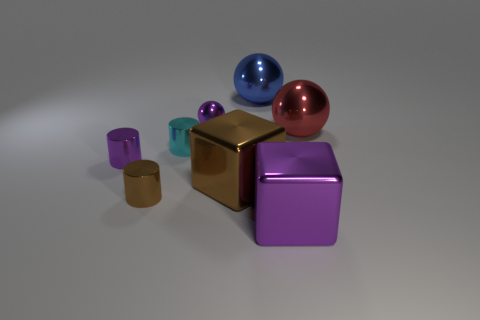How many other objects are there of the same material as the small sphere?
Make the answer very short. 7. What is the color of the big thing that is in front of the red sphere and behind the purple shiny cube?
Provide a succinct answer. Brown. Is the big block that is to the right of the large blue sphere made of the same material as the cube that is to the left of the blue ball?
Make the answer very short. Yes. Is the size of the brown metallic object on the left side of the purple ball the same as the tiny cyan cylinder?
Provide a short and direct response. Yes. There is a small ball; is it the same color as the metallic cube on the right side of the large blue object?
Provide a short and direct response. Yes. There is a big metallic object that is the same color as the small ball; what shape is it?
Offer a very short reply. Cube. There is a big brown thing; what shape is it?
Offer a terse response. Cube. How many things are big balls that are on the right side of the blue metal object or small yellow cylinders?
Give a very brief answer. 1. The cyan cylinder that is made of the same material as the tiny brown object is what size?
Offer a very short reply. Small. Is the number of small cyan cylinders in front of the large red object greater than the number of small red matte cylinders?
Provide a succinct answer. Yes. 